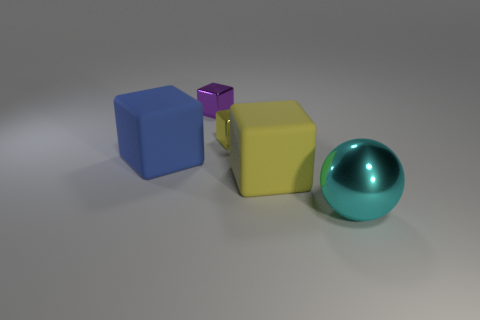Subtract all small purple cubes. How many cubes are left? 3 Subtract all purple cubes. How many cubes are left? 3 Add 4 cyan things. How many objects exist? 9 Subtract all green cubes. Subtract all brown cylinders. How many cubes are left? 4 Subtract all cubes. How many objects are left? 1 Subtract all large blue cubes. Subtract all blocks. How many objects are left? 0 Add 1 large objects. How many large objects are left? 4 Add 5 tiny purple metallic cubes. How many tiny purple metallic cubes exist? 6 Subtract 0 purple cylinders. How many objects are left? 5 